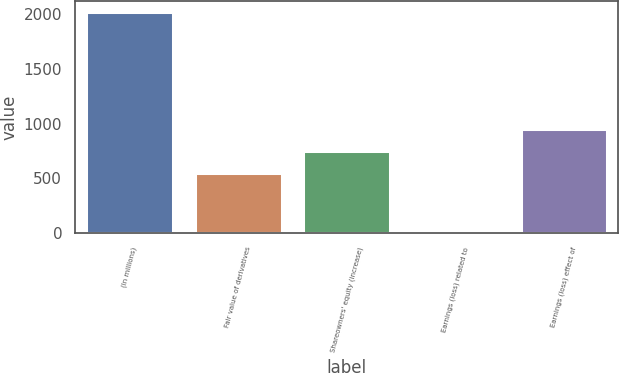Convert chart. <chart><loc_0><loc_0><loc_500><loc_500><bar_chart><fcel>(In millions)<fcel>Fair value of derivatives<fcel>Shareowners' equity (increase)<fcel>Earnings (loss) related to<fcel>Earnings (loss) effect of<nl><fcel>2014<fcel>546<fcel>747.3<fcel>1<fcel>948.6<nl></chart> 